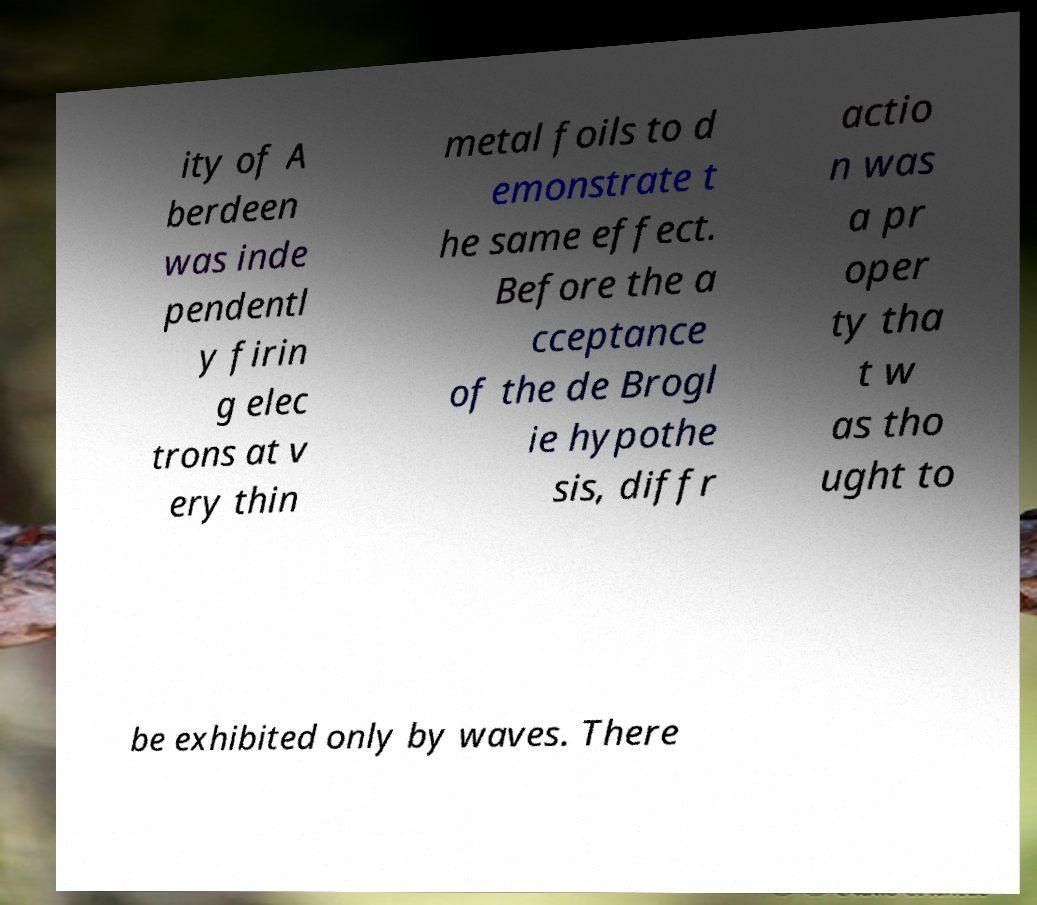Please identify and transcribe the text found in this image. ity of A berdeen was inde pendentl y firin g elec trons at v ery thin metal foils to d emonstrate t he same effect. Before the a cceptance of the de Brogl ie hypothe sis, diffr actio n was a pr oper ty tha t w as tho ught to be exhibited only by waves. There 